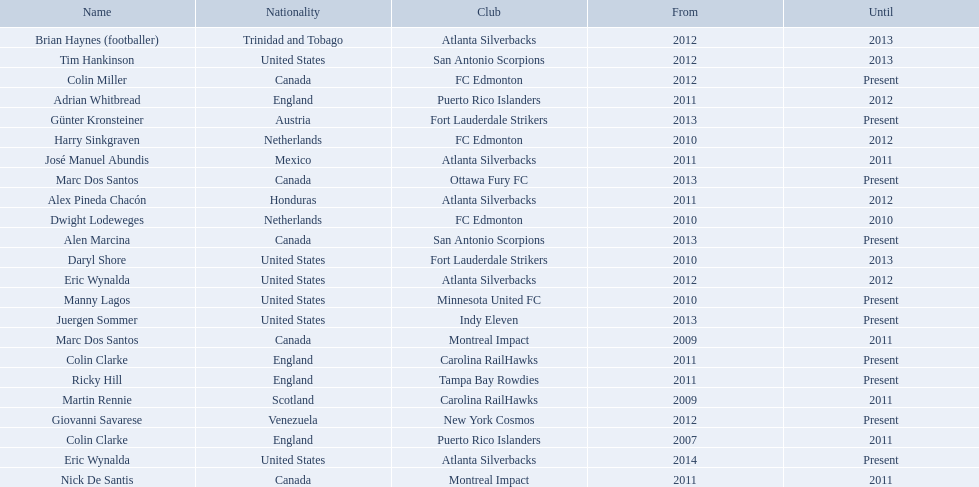What year did marc dos santos start as coach? 2009. Which other starting years correspond with this year? 2009. Who was the other coach with this starting year Martin Rennie. 